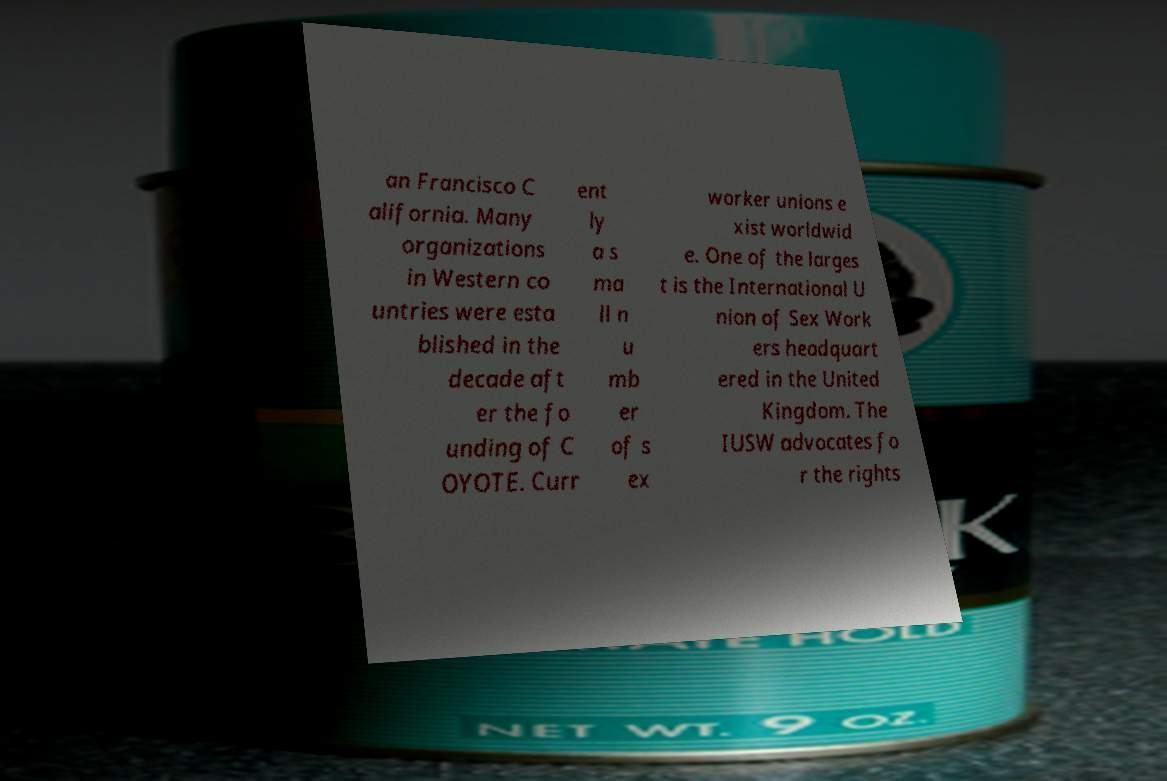For documentation purposes, I need the text within this image transcribed. Could you provide that? an Francisco C alifornia. Many organizations in Western co untries were esta blished in the decade aft er the fo unding of C OYOTE. Curr ent ly a s ma ll n u mb er of s ex worker unions e xist worldwid e. One of the larges t is the International U nion of Sex Work ers headquart ered in the United Kingdom. The IUSW advocates fo r the rights 